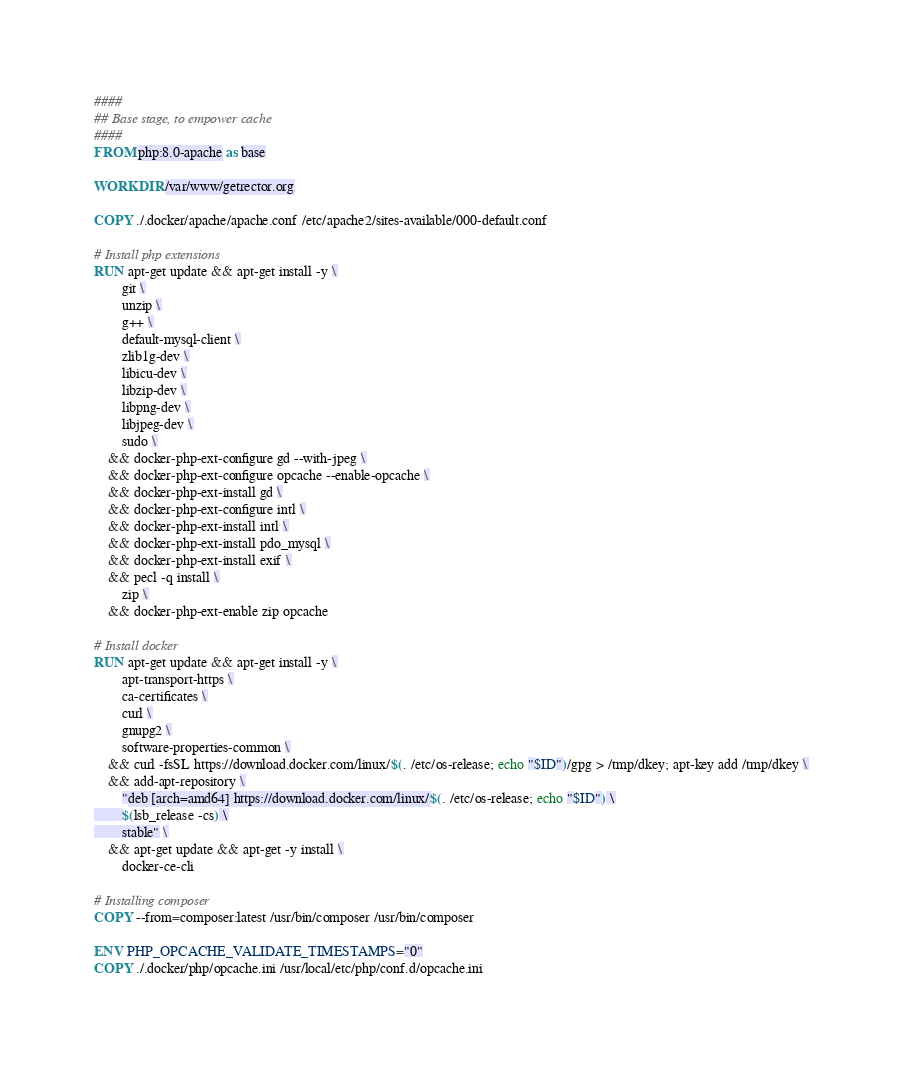<code> <loc_0><loc_0><loc_500><loc_500><_Dockerfile_>####
## Base stage, to empower cache
####
FROM php:8.0-apache as base

WORKDIR /var/www/getrector.org

COPY ./.docker/apache/apache.conf /etc/apache2/sites-available/000-default.conf

# Install php extensions
RUN apt-get update && apt-get install -y \
        git \
        unzip \
        g++ \
        default-mysql-client \
        zlib1g-dev \
        libicu-dev \
        libzip-dev \
        libpng-dev \
        libjpeg-dev \
        sudo \
    && docker-php-ext-configure gd --with-jpeg \
    && docker-php-ext-configure opcache --enable-opcache \
    && docker-php-ext-install gd \
    && docker-php-ext-configure intl \
    && docker-php-ext-install intl \
    && docker-php-ext-install pdo_mysql \
    && docker-php-ext-install exif \
    && pecl -q install \
        zip \
    && docker-php-ext-enable zip opcache

# Install docker
RUN apt-get update && apt-get install -y \
        apt-transport-https \
        ca-certificates \
        curl \
        gnupg2 \
        software-properties-common \
    && curl -fsSL https://download.docker.com/linux/$(. /etc/os-release; echo "$ID")/gpg > /tmp/dkey; apt-key add /tmp/dkey \
    && add-apt-repository \
        "deb [arch=amd64] https://download.docker.com/linux/$(. /etc/os-release; echo "$ID") \
        $(lsb_release -cs) \
        stable" \
    && apt-get update && apt-get -y install \
        docker-ce-cli

# Installing composer
COPY --from=composer:latest /usr/bin/composer /usr/bin/composer

ENV PHP_OPCACHE_VALIDATE_TIMESTAMPS="0"
COPY ./.docker/php/opcache.ini /usr/local/etc/php/conf.d/opcache.ini
</code> 